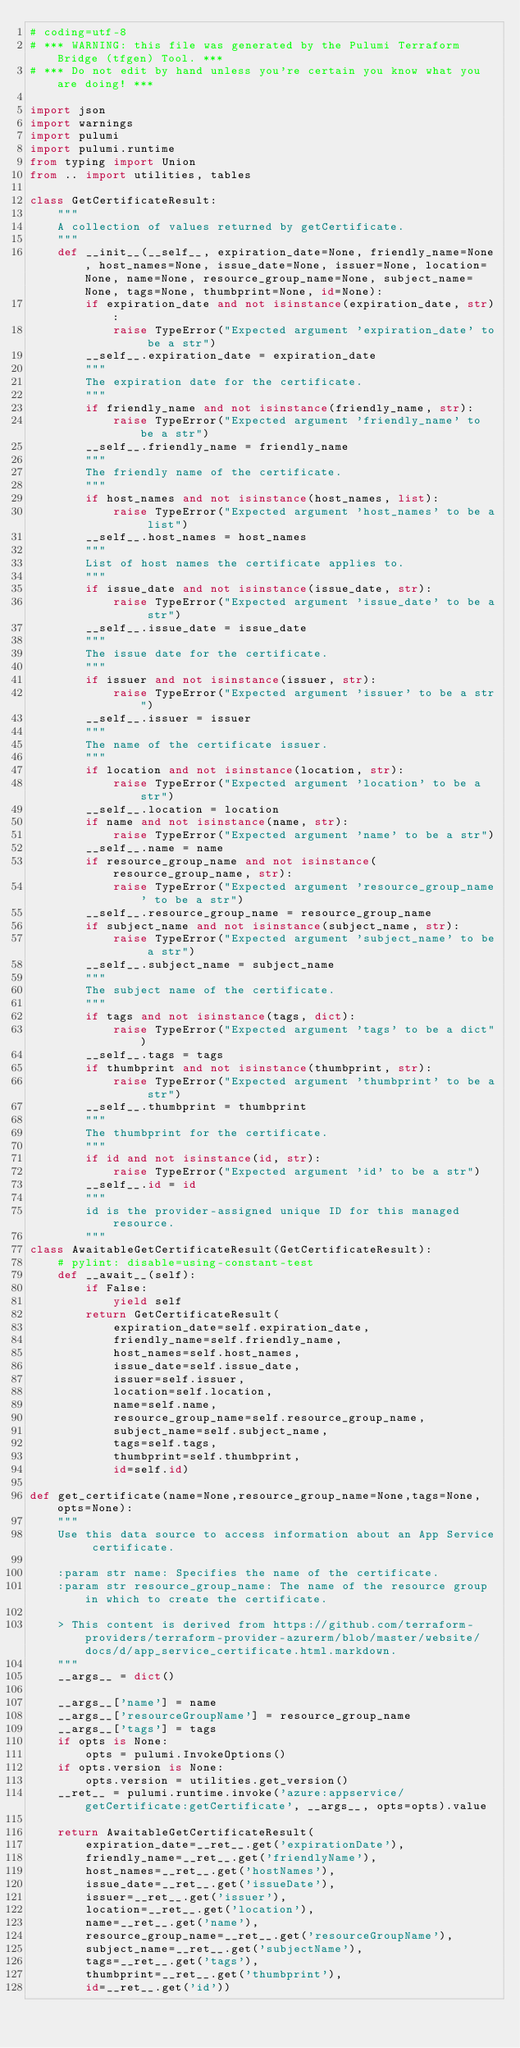<code> <loc_0><loc_0><loc_500><loc_500><_Python_># coding=utf-8
# *** WARNING: this file was generated by the Pulumi Terraform Bridge (tfgen) Tool. ***
# *** Do not edit by hand unless you're certain you know what you are doing! ***

import json
import warnings
import pulumi
import pulumi.runtime
from typing import Union
from .. import utilities, tables

class GetCertificateResult:
    """
    A collection of values returned by getCertificate.
    """
    def __init__(__self__, expiration_date=None, friendly_name=None, host_names=None, issue_date=None, issuer=None, location=None, name=None, resource_group_name=None, subject_name=None, tags=None, thumbprint=None, id=None):
        if expiration_date and not isinstance(expiration_date, str):
            raise TypeError("Expected argument 'expiration_date' to be a str")
        __self__.expiration_date = expiration_date
        """
        The expiration date for the certificate.
        """
        if friendly_name and not isinstance(friendly_name, str):
            raise TypeError("Expected argument 'friendly_name' to be a str")
        __self__.friendly_name = friendly_name
        """
        The friendly name of the certificate.
        """
        if host_names and not isinstance(host_names, list):
            raise TypeError("Expected argument 'host_names' to be a list")
        __self__.host_names = host_names
        """
        List of host names the certificate applies to.
        """
        if issue_date and not isinstance(issue_date, str):
            raise TypeError("Expected argument 'issue_date' to be a str")
        __self__.issue_date = issue_date
        """
        The issue date for the certificate.
        """
        if issuer and not isinstance(issuer, str):
            raise TypeError("Expected argument 'issuer' to be a str")
        __self__.issuer = issuer
        """
        The name of the certificate issuer.
        """
        if location and not isinstance(location, str):
            raise TypeError("Expected argument 'location' to be a str")
        __self__.location = location
        if name and not isinstance(name, str):
            raise TypeError("Expected argument 'name' to be a str")
        __self__.name = name
        if resource_group_name and not isinstance(resource_group_name, str):
            raise TypeError("Expected argument 'resource_group_name' to be a str")
        __self__.resource_group_name = resource_group_name
        if subject_name and not isinstance(subject_name, str):
            raise TypeError("Expected argument 'subject_name' to be a str")
        __self__.subject_name = subject_name
        """
        The subject name of the certificate.
        """
        if tags and not isinstance(tags, dict):
            raise TypeError("Expected argument 'tags' to be a dict")
        __self__.tags = tags
        if thumbprint and not isinstance(thumbprint, str):
            raise TypeError("Expected argument 'thumbprint' to be a str")
        __self__.thumbprint = thumbprint
        """
        The thumbprint for the certificate.
        """
        if id and not isinstance(id, str):
            raise TypeError("Expected argument 'id' to be a str")
        __self__.id = id
        """
        id is the provider-assigned unique ID for this managed resource.
        """
class AwaitableGetCertificateResult(GetCertificateResult):
    # pylint: disable=using-constant-test
    def __await__(self):
        if False:
            yield self
        return GetCertificateResult(
            expiration_date=self.expiration_date,
            friendly_name=self.friendly_name,
            host_names=self.host_names,
            issue_date=self.issue_date,
            issuer=self.issuer,
            location=self.location,
            name=self.name,
            resource_group_name=self.resource_group_name,
            subject_name=self.subject_name,
            tags=self.tags,
            thumbprint=self.thumbprint,
            id=self.id)

def get_certificate(name=None,resource_group_name=None,tags=None,opts=None):
    """
    Use this data source to access information about an App Service certificate.
    
    :param str name: Specifies the name of the certificate.
    :param str resource_group_name: The name of the resource group in which to create the certificate.

    > This content is derived from https://github.com/terraform-providers/terraform-provider-azurerm/blob/master/website/docs/d/app_service_certificate.html.markdown.
    """
    __args__ = dict()

    __args__['name'] = name
    __args__['resourceGroupName'] = resource_group_name
    __args__['tags'] = tags
    if opts is None:
        opts = pulumi.InvokeOptions()
    if opts.version is None:
        opts.version = utilities.get_version()
    __ret__ = pulumi.runtime.invoke('azure:appservice/getCertificate:getCertificate', __args__, opts=opts).value

    return AwaitableGetCertificateResult(
        expiration_date=__ret__.get('expirationDate'),
        friendly_name=__ret__.get('friendlyName'),
        host_names=__ret__.get('hostNames'),
        issue_date=__ret__.get('issueDate'),
        issuer=__ret__.get('issuer'),
        location=__ret__.get('location'),
        name=__ret__.get('name'),
        resource_group_name=__ret__.get('resourceGroupName'),
        subject_name=__ret__.get('subjectName'),
        tags=__ret__.get('tags'),
        thumbprint=__ret__.get('thumbprint'),
        id=__ret__.get('id'))
</code> 